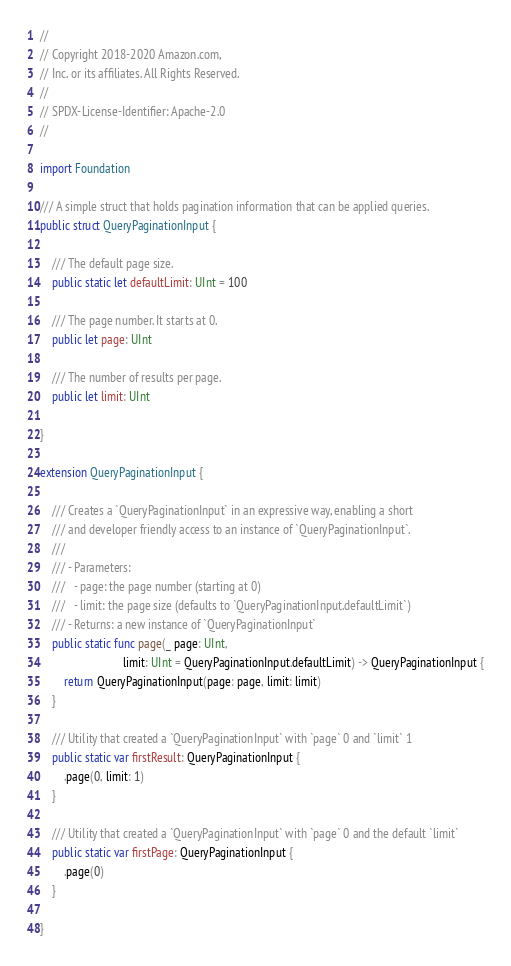Convert code to text. <code><loc_0><loc_0><loc_500><loc_500><_Swift_>//
// Copyright 2018-2020 Amazon.com,
// Inc. or its affiliates. All Rights Reserved.
//
// SPDX-License-Identifier: Apache-2.0
//

import Foundation

/// A simple struct that holds pagination information that can be applied queries.
public struct QueryPaginationInput {

    /// The default page size.
    public static let defaultLimit: UInt = 100

    /// The page number. It starts at 0.
    public let page: UInt

    /// The number of results per page.
    public let limit: UInt

}

extension QueryPaginationInput {

    /// Creates a `QueryPaginationInput` in an expressive way, enabling a short
    /// and developer friendly access to an instance of `QueryPaginationInput`.
    ///
    /// - Parameters:
    ///   - page: the page number (starting at 0)
    ///   - limit: the page size (defaults to `QueryPaginationInput.defaultLimit`)
    /// - Returns: a new instance of `QueryPaginationInput`
    public static func page(_ page: UInt,
                            limit: UInt = QueryPaginationInput.defaultLimit) -> QueryPaginationInput {
        return QueryPaginationInput(page: page, limit: limit)
    }

    /// Utility that created a `QueryPaginationInput` with `page` 0 and `limit` 1
    public static var firstResult: QueryPaginationInput {
        .page(0, limit: 1)
    }

    /// Utility that created a `QueryPaginationInput` with `page` 0 and the default `limit`
    public static var firstPage: QueryPaginationInput {
        .page(0)
    }

}
</code> 